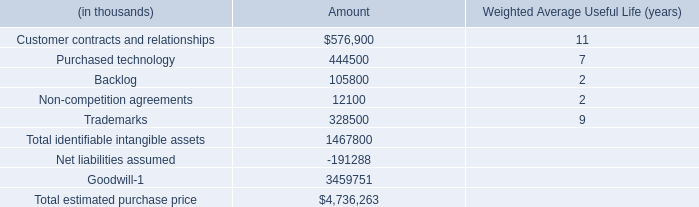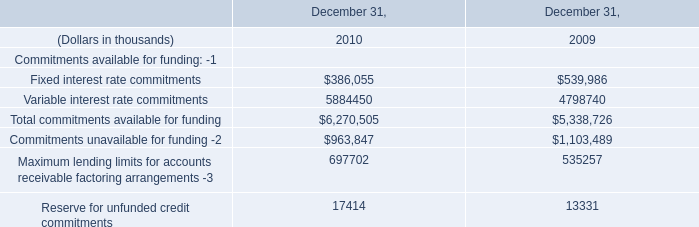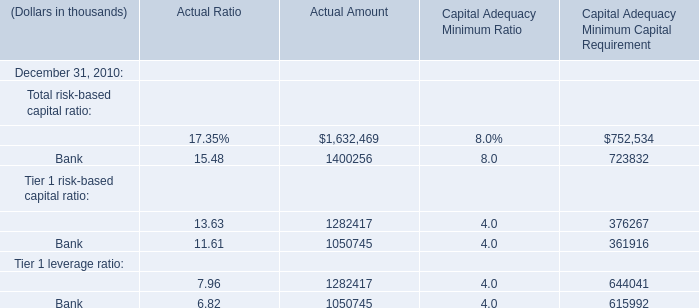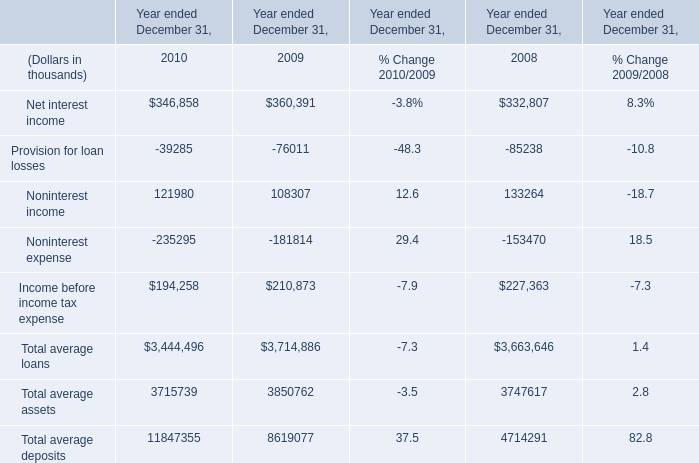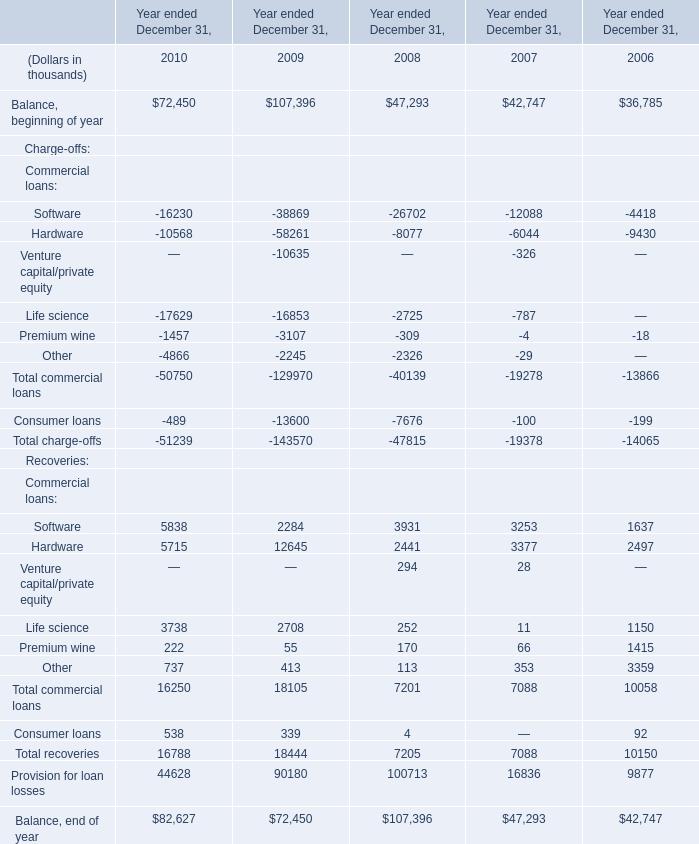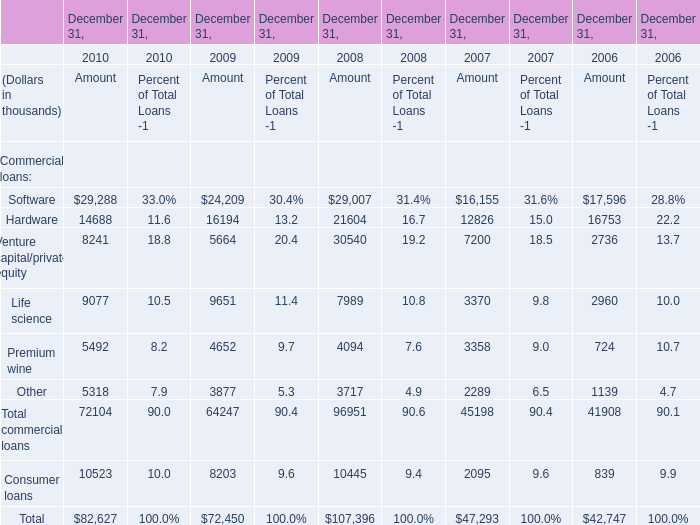What was the amount of the Other commercial loans on December 31 in the year where Total commercial loans on December 31 is greater than 90000 thousand? (in thousand) 
Answer: 3717. 